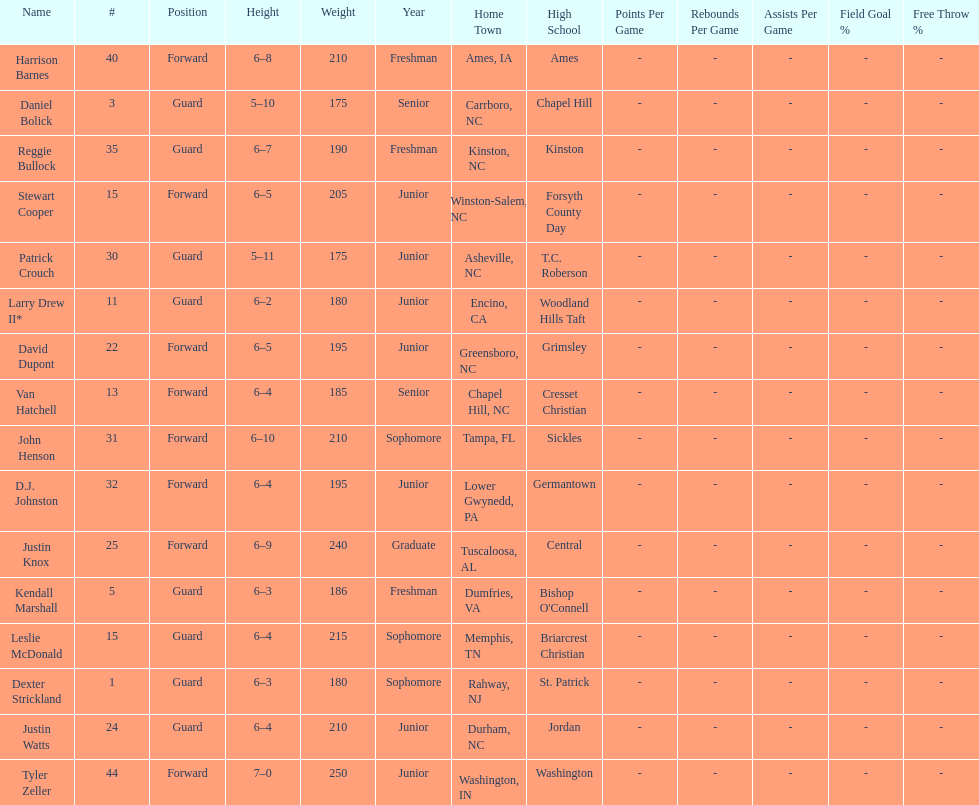How many players were taller than van hatchell? 7. 